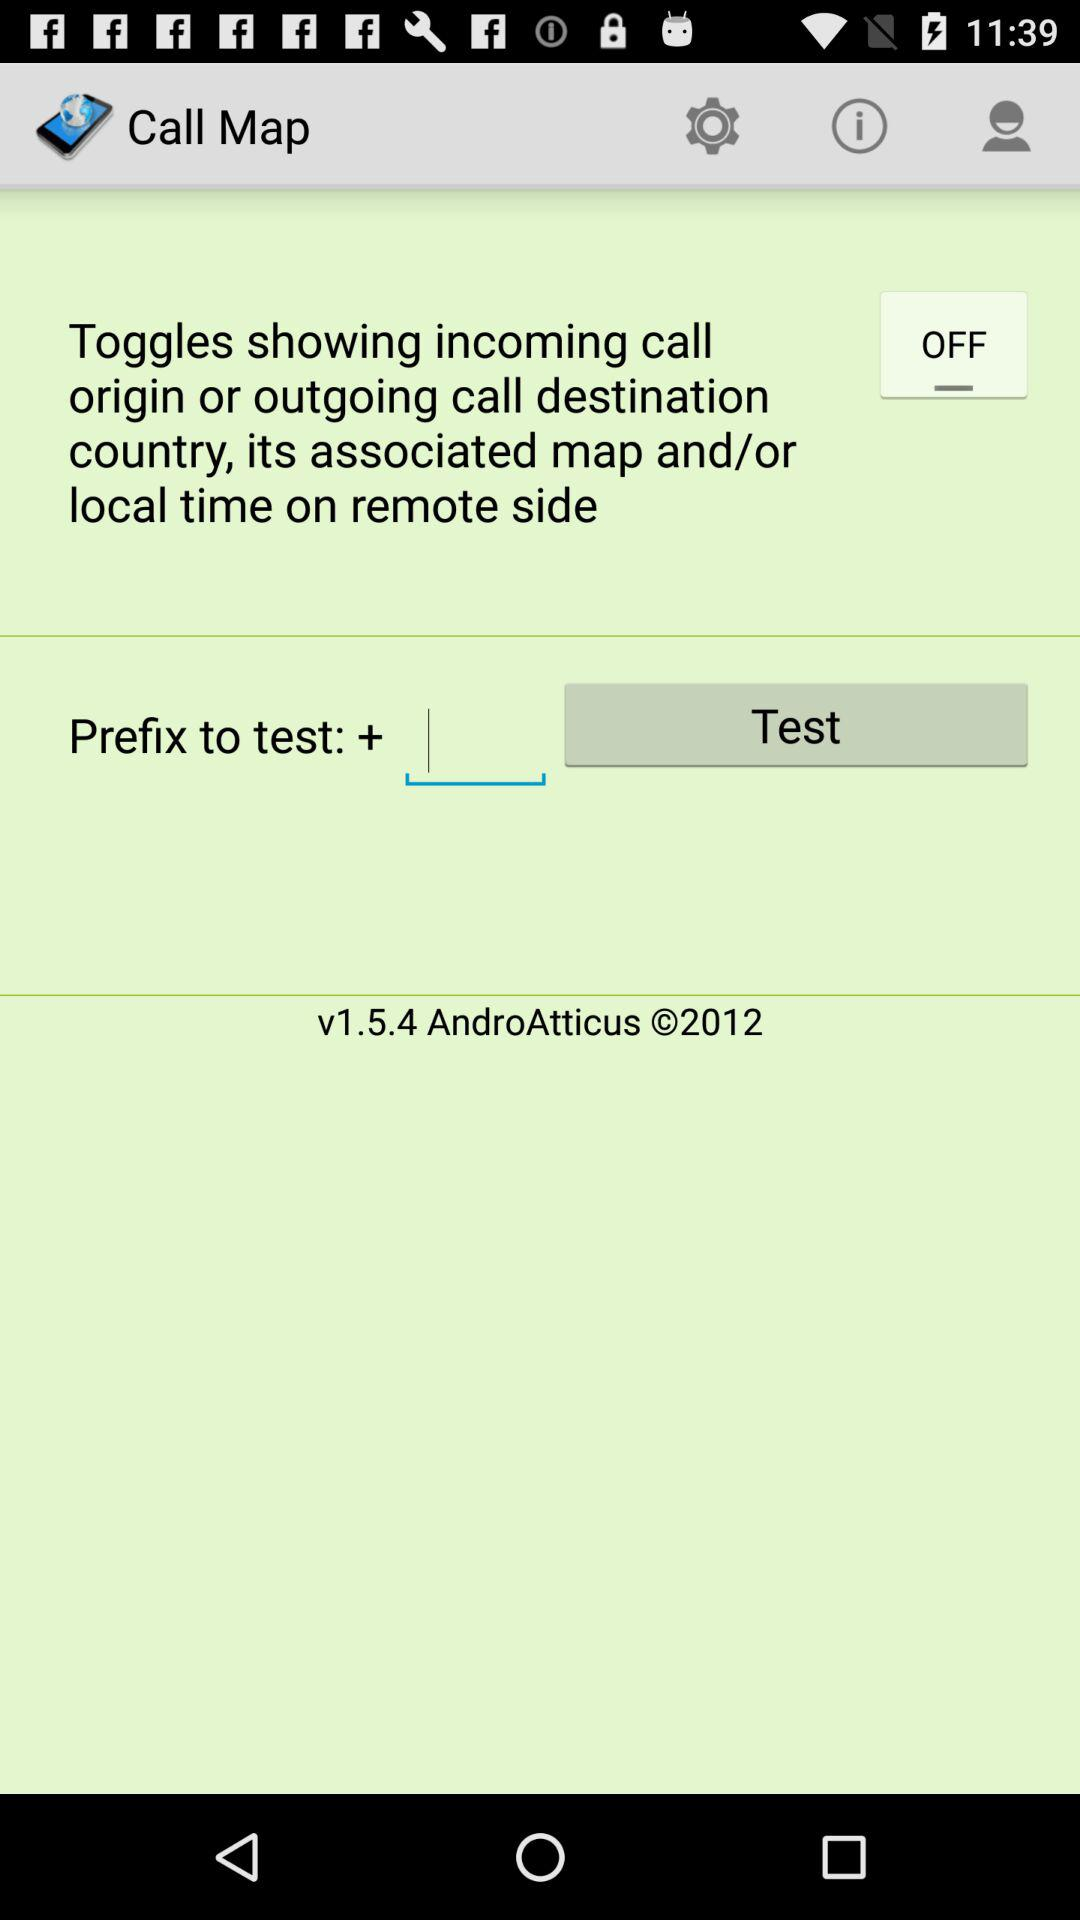What is the status of "Toggles showing incoming call origin"? The status is "off". 